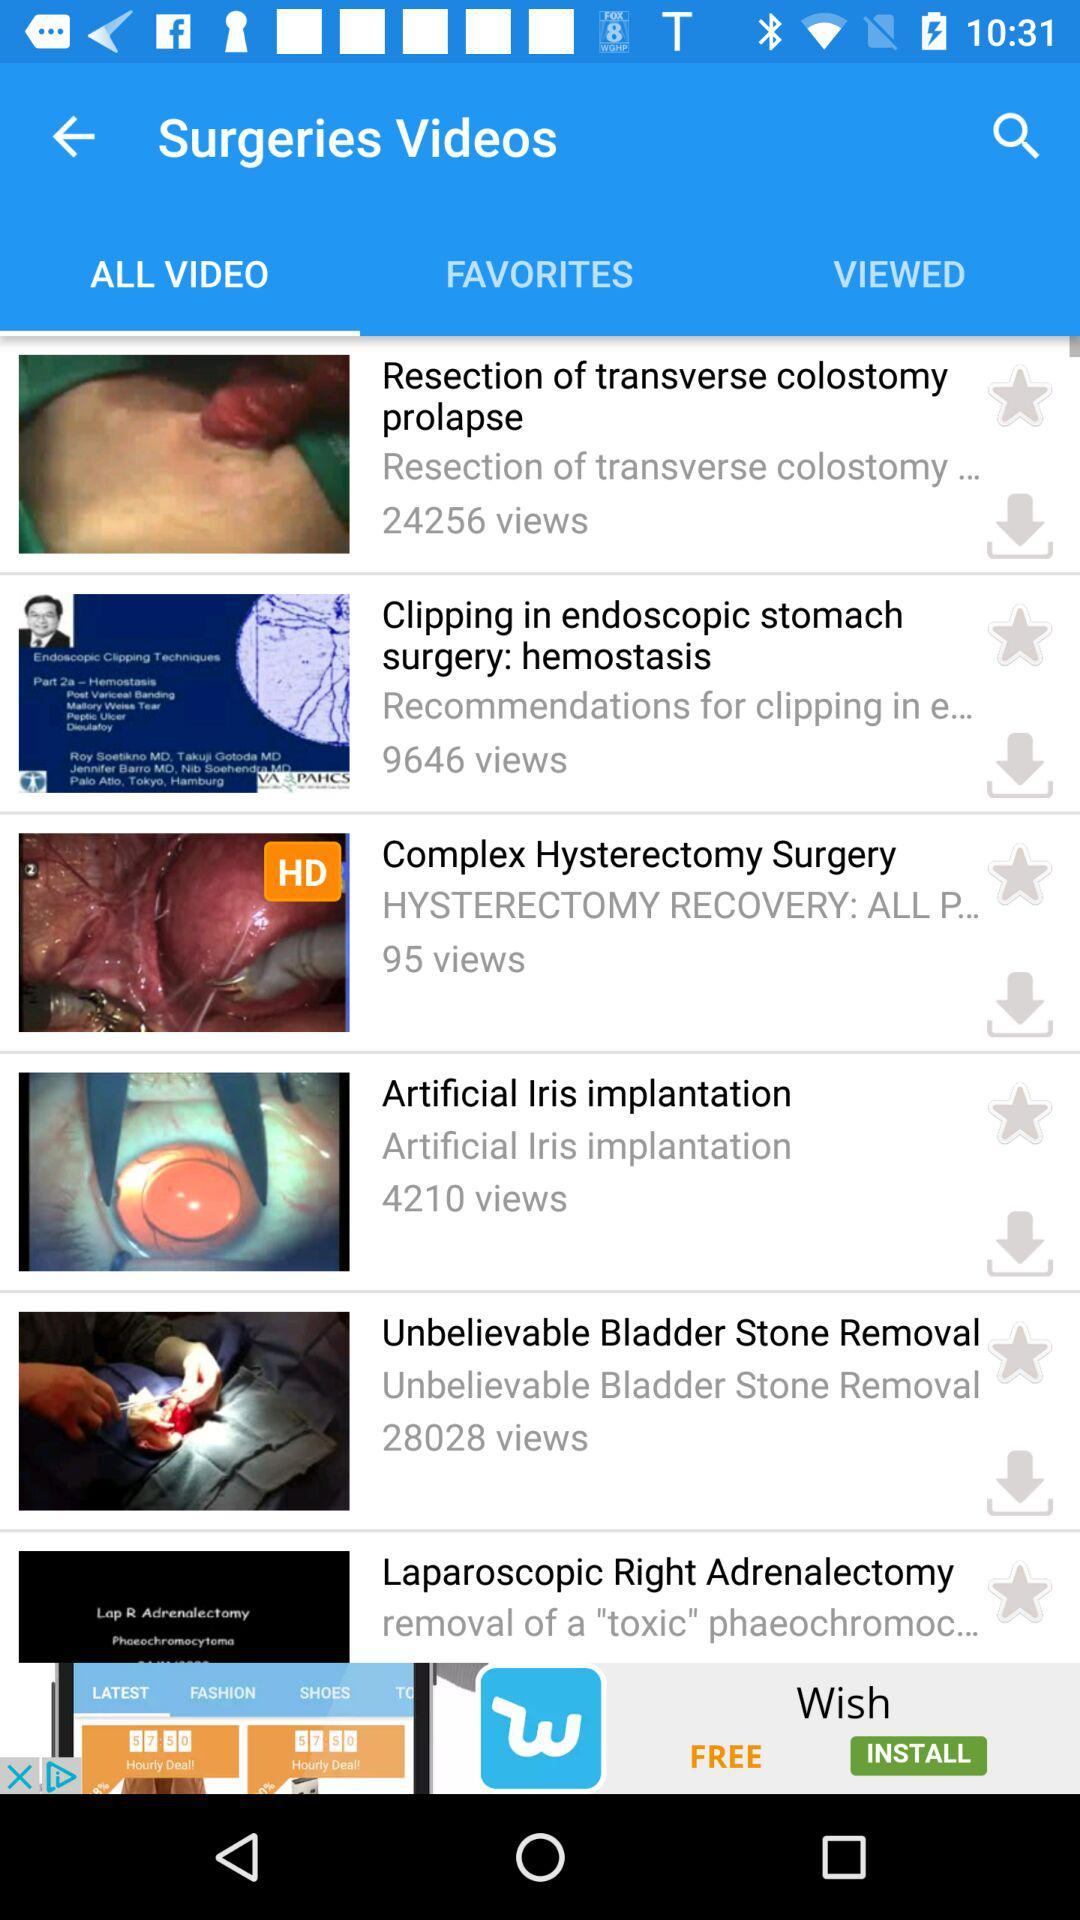Which video has received 95 views? The video that has received 95 views is "Complex Hysterectomy Surgery". 